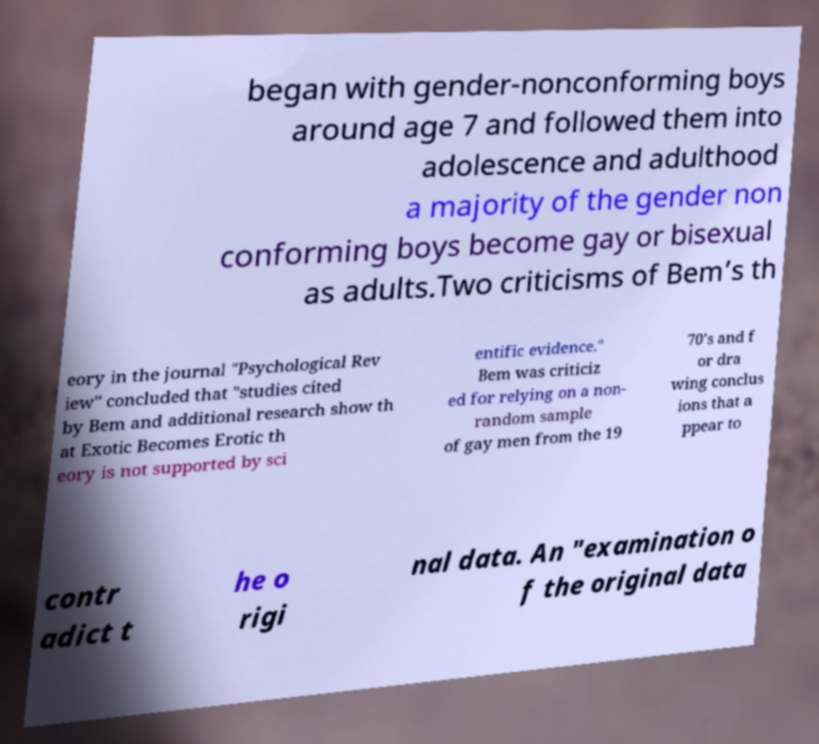Could you extract and type out the text from this image? began with gender-nonconforming boys around age 7 and followed them into adolescence and adulthood a majority of the gender non conforming boys become gay or bisexual as adults.Two criticisms of Bem’s th eory in the journal "Psychological Rev iew" concluded that "studies cited by Bem and additional research show th at Exotic Becomes Erotic th eory is not supported by sci entific evidence." Bem was criticiz ed for relying on a non- random sample of gay men from the 19 70's and f or dra wing conclus ions that a ppear to contr adict t he o rigi nal data. An "examination o f the original data 